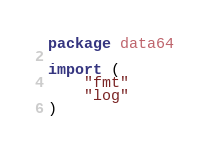<code> <loc_0><loc_0><loc_500><loc_500><_Go_>package data64

import (
	"fmt"
	"log"
)
</code> 